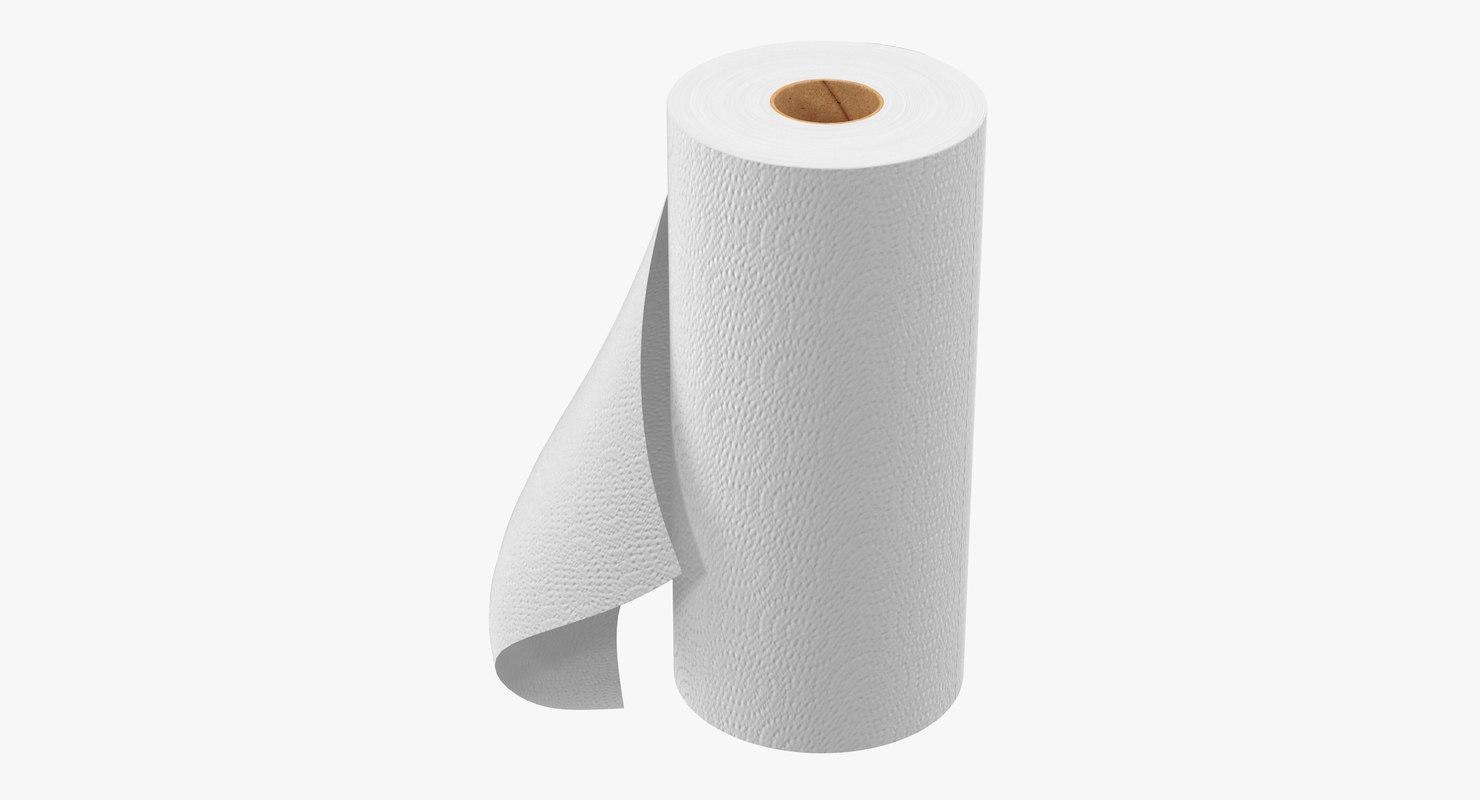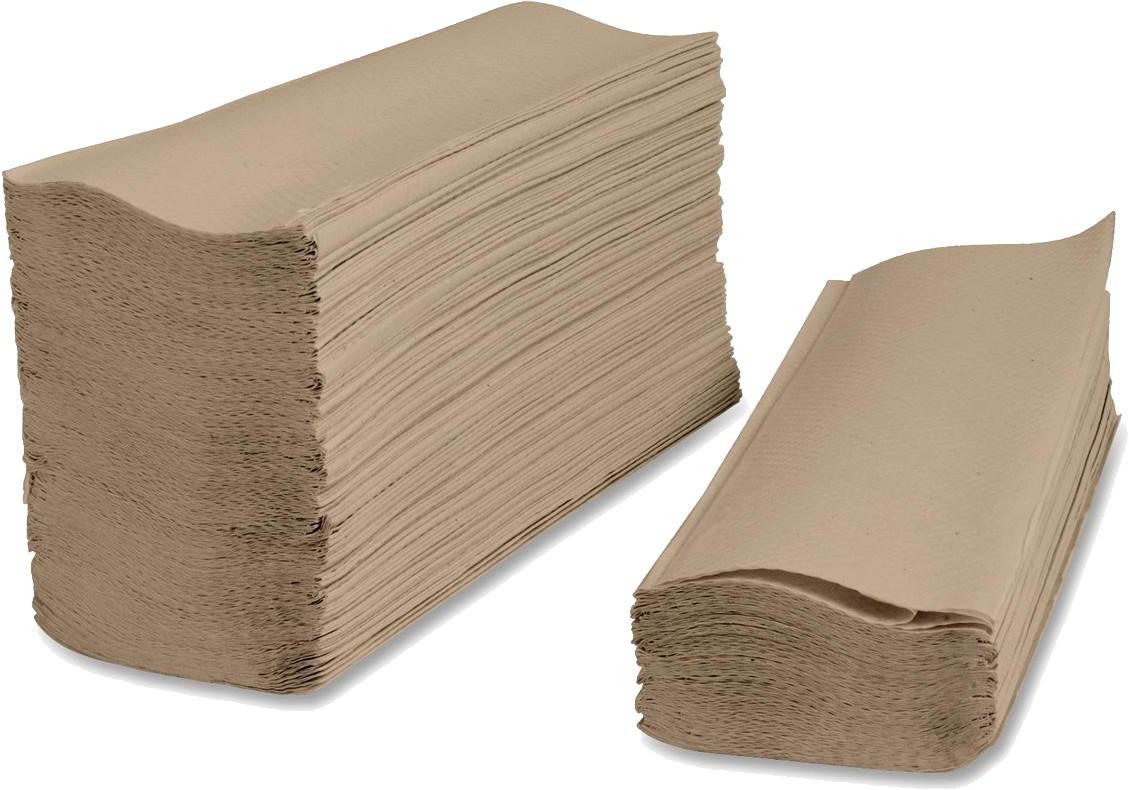The first image is the image on the left, the second image is the image on the right. For the images displayed, is the sentence "There is a brown roll of paper towels in the image on the right." factually correct? Answer yes or no. No. The first image is the image on the left, the second image is the image on the right. Assess this claim about the two images: "there is exactly one standing roll of paper towels in the image on the left". Correct or not? Answer yes or no. Yes. 